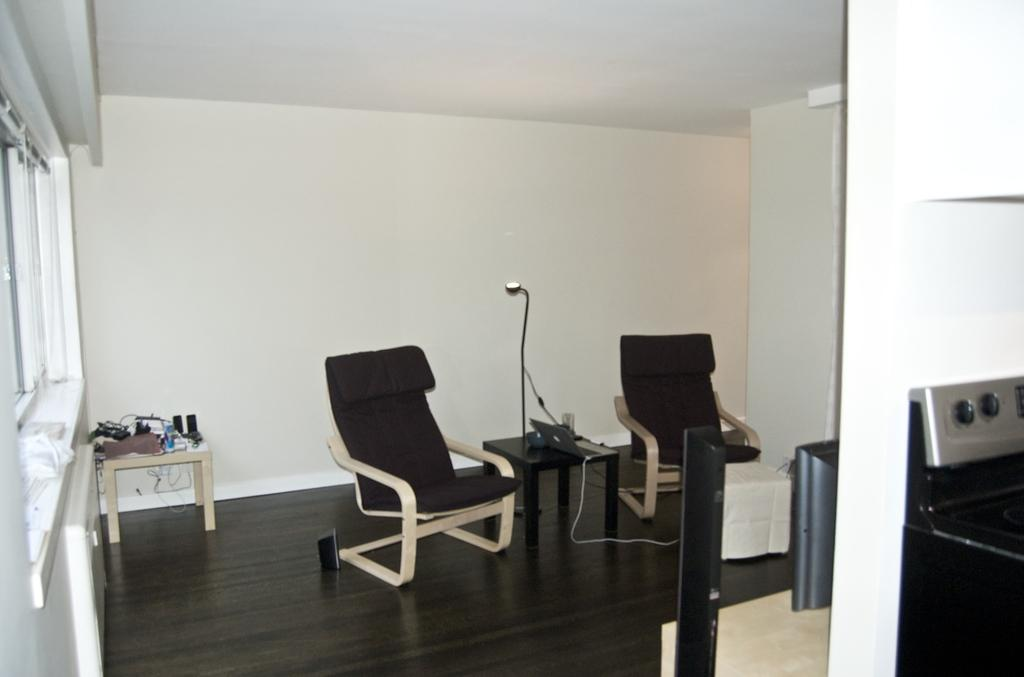What type of furniture is located on the left side of the image? There are chairs on the left side of the image. What architectural feature can be seen in the image? There is a window in the image. What is the average income of the cubs in the image? There are no cubs present in the image, so it is not possible to determine their average income. 